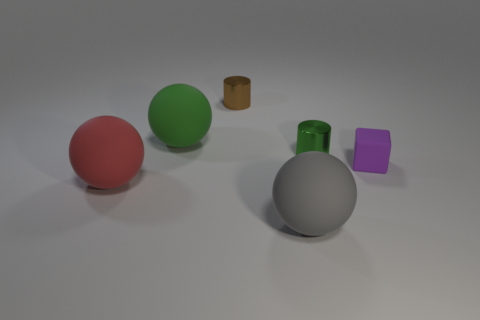Add 4 big purple metal cylinders. How many objects exist? 10 Subtract all cylinders. How many objects are left? 4 Subtract all cyan matte spheres. Subtract all tiny purple matte things. How many objects are left? 5 Add 2 purple rubber things. How many purple rubber things are left? 3 Add 6 tiny spheres. How many tiny spheres exist? 6 Subtract 0 blue cylinders. How many objects are left? 6 